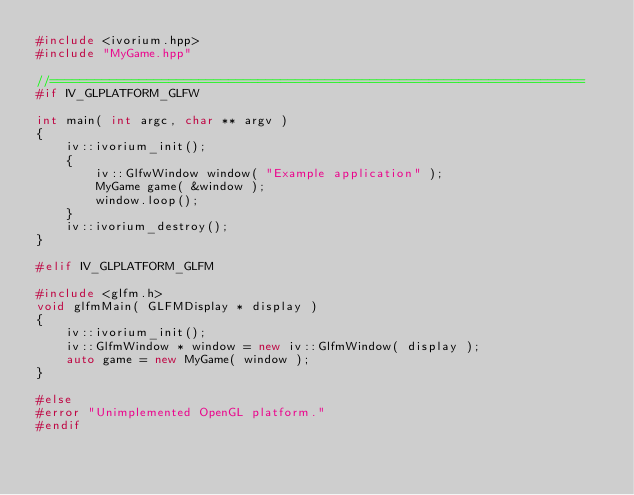Convert code to text. <code><loc_0><loc_0><loc_500><loc_500><_C++_>#include <ivorium.hpp>
#include "MyGame.hpp"

//========================================================================
#if IV_GLPLATFORM_GLFW

int main( int argc, char ** argv )
{
	iv::ivorium_init();
    {
        iv::GlfwWindow window( "Example application" );
        MyGame game( &window );
        window.loop();
    }
    iv::ivorium_destroy();
}

#elif IV_GLPLATFORM_GLFM

#include <glfm.h>
void glfmMain( GLFMDisplay * display )
{
	iv::ivorium_init();
	iv::GlfmWindow * window = new iv::GlfmWindow( display );
	auto game = new MyGame( window );
}

#else
#error "Unimplemented OpenGL platform."
#endif
</code> 